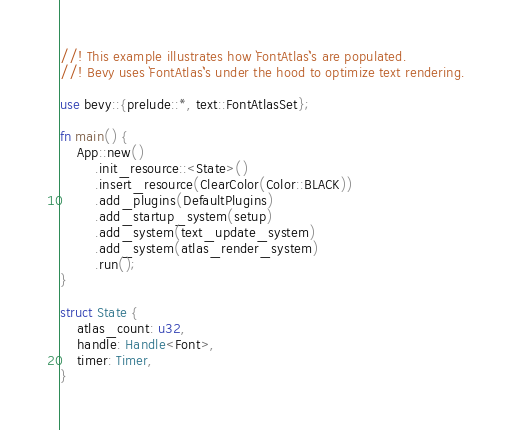Convert code to text. <code><loc_0><loc_0><loc_500><loc_500><_Rust_>//! This example illustrates how `FontAtlas`'s are populated.
//! Bevy uses `FontAtlas`'s under the hood to optimize text rendering.

use bevy::{prelude::*, text::FontAtlasSet};

fn main() {
    App::new()
        .init_resource::<State>()
        .insert_resource(ClearColor(Color::BLACK))
        .add_plugins(DefaultPlugins)
        .add_startup_system(setup)
        .add_system(text_update_system)
        .add_system(atlas_render_system)
        .run();
}

struct State {
    atlas_count: u32,
    handle: Handle<Font>,
    timer: Timer,
}
</code> 